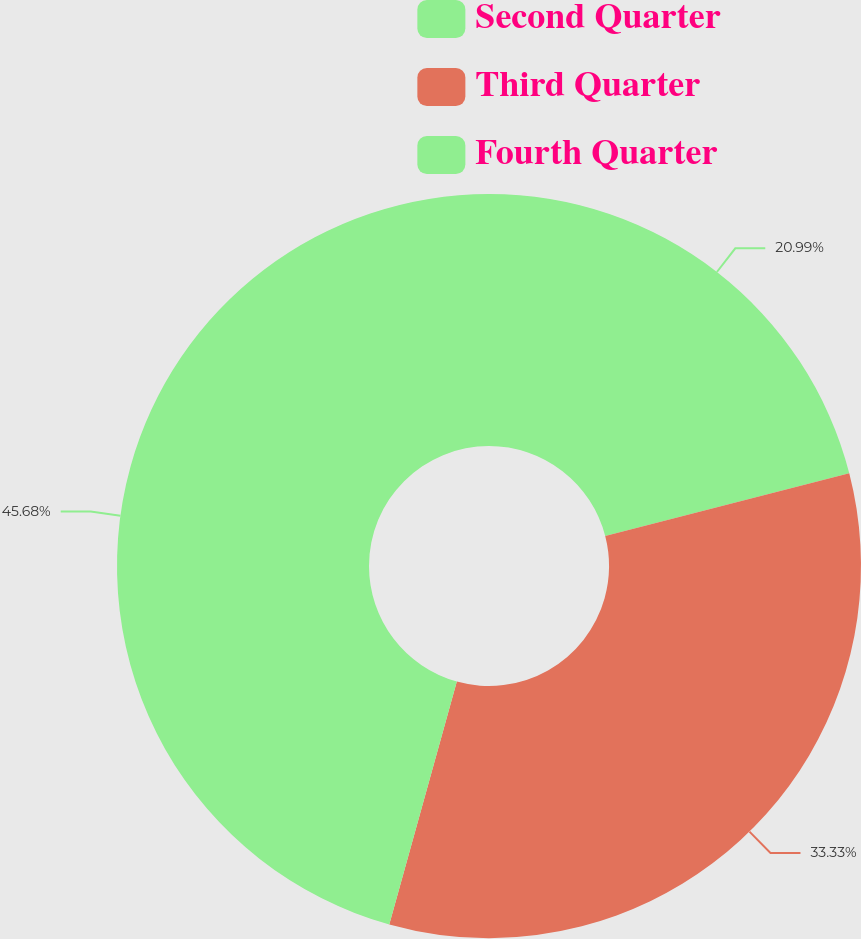Convert chart. <chart><loc_0><loc_0><loc_500><loc_500><pie_chart><fcel>Second Quarter<fcel>Third Quarter<fcel>Fourth Quarter<nl><fcel>20.99%<fcel>33.33%<fcel>45.68%<nl></chart> 